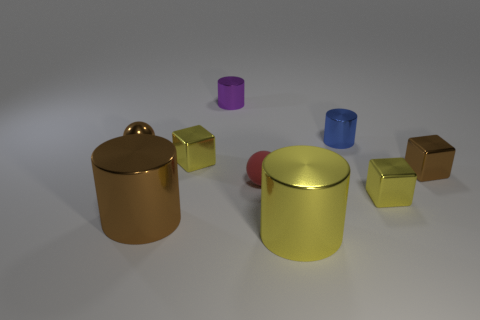What time of day does the lighting in this image suggest? The soft, diffuse lighting in the image, along with faint shadows, suggests early morning or late afternoon when the sun is lower in the sky, casting a gentle light. However, considering the controlled environment this could indicate artificial lighting designed to imitate these natural conditions. 